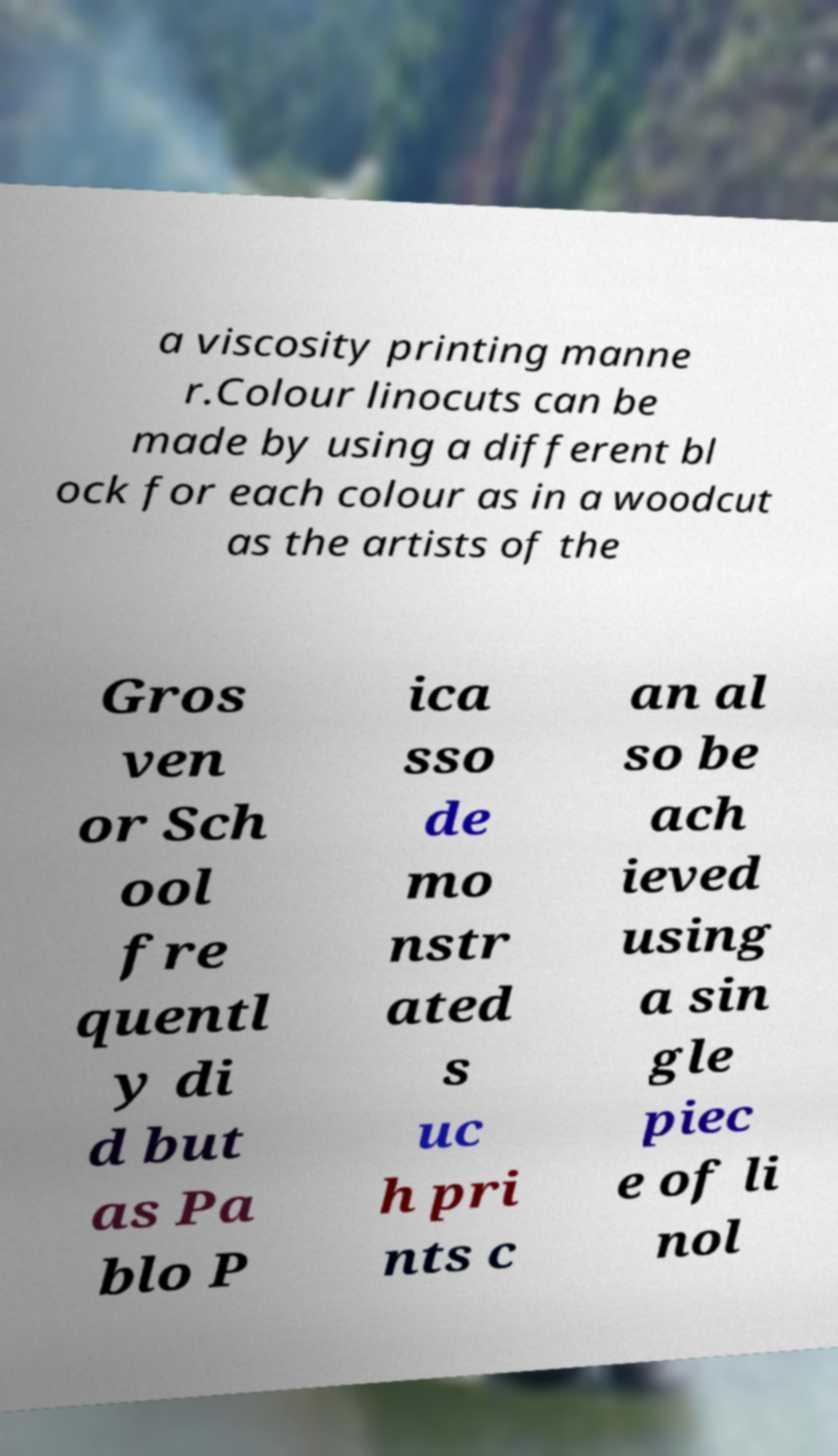Could you assist in decoding the text presented in this image and type it out clearly? a viscosity printing manne r.Colour linocuts can be made by using a different bl ock for each colour as in a woodcut as the artists of the Gros ven or Sch ool fre quentl y di d but as Pa blo P ica sso de mo nstr ated s uc h pri nts c an al so be ach ieved using a sin gle piec e of li nol 